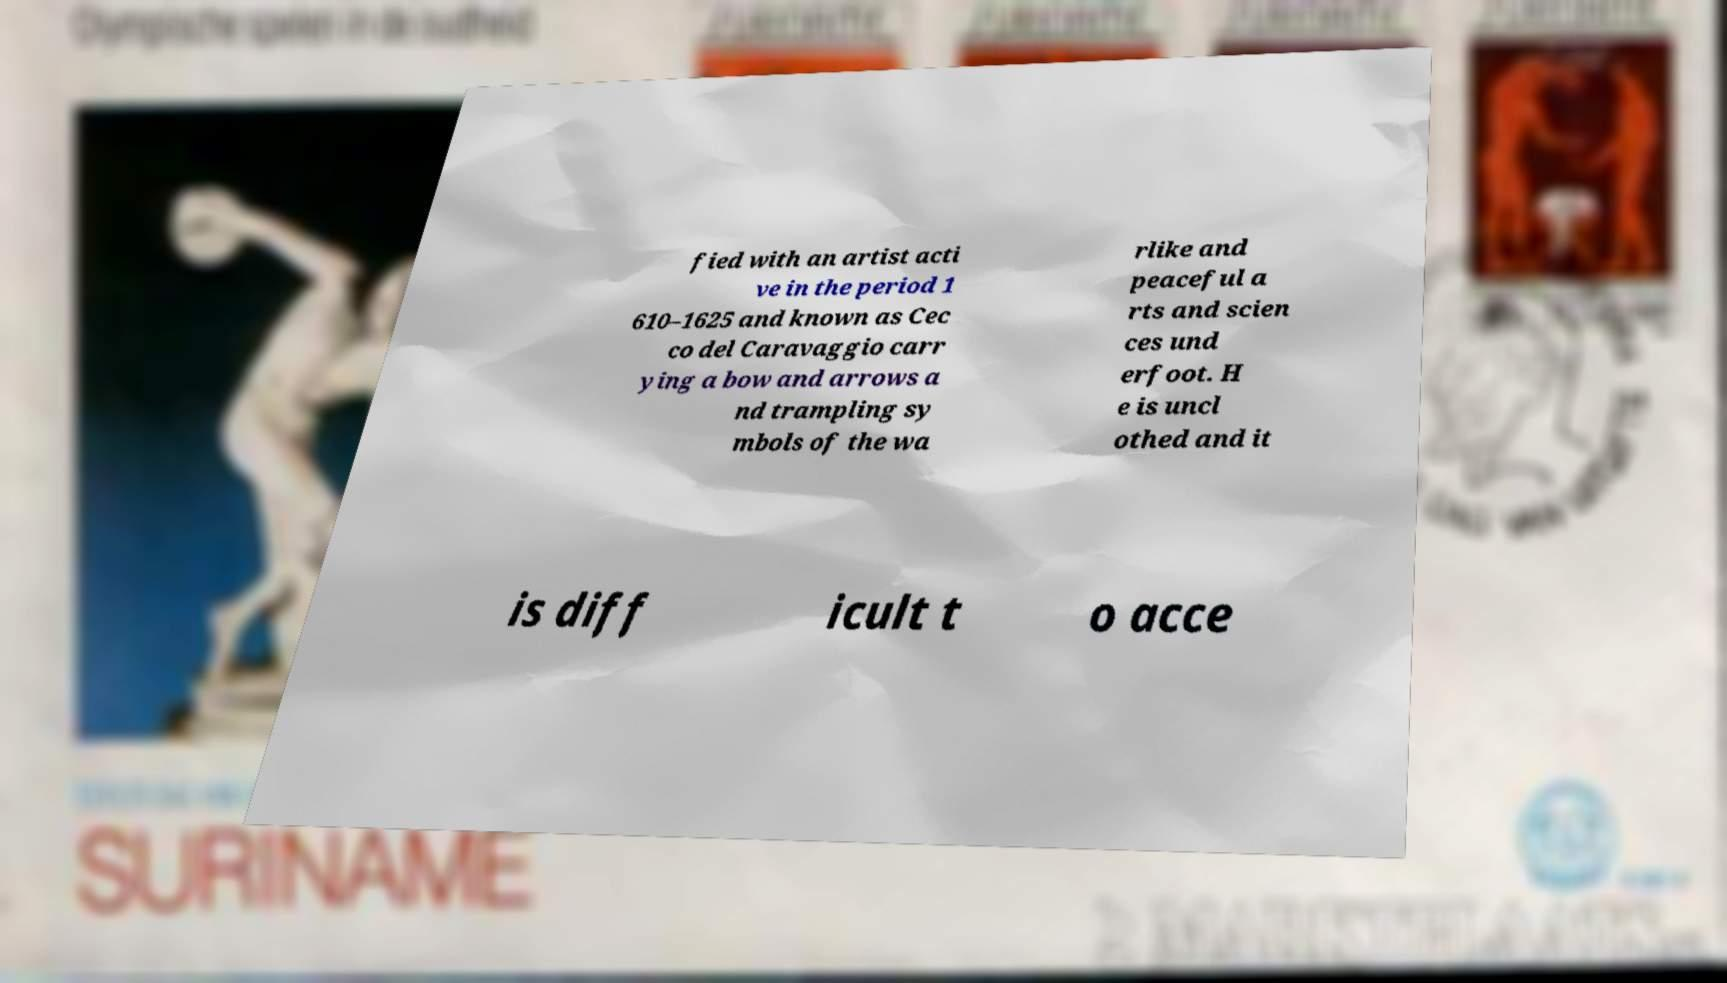What messages or text are displayed in this image? I need them in a readable, typed format. fied with an artist acti ve in the period 1 610–1625 and known as Cec co del Caravaggio carr ying a bow and arrows a nd trampling sy mbols of the wa rlike and peaceful a rts and scien ces und erfoot. H e is uncl othed and it is diff icult t o acce 